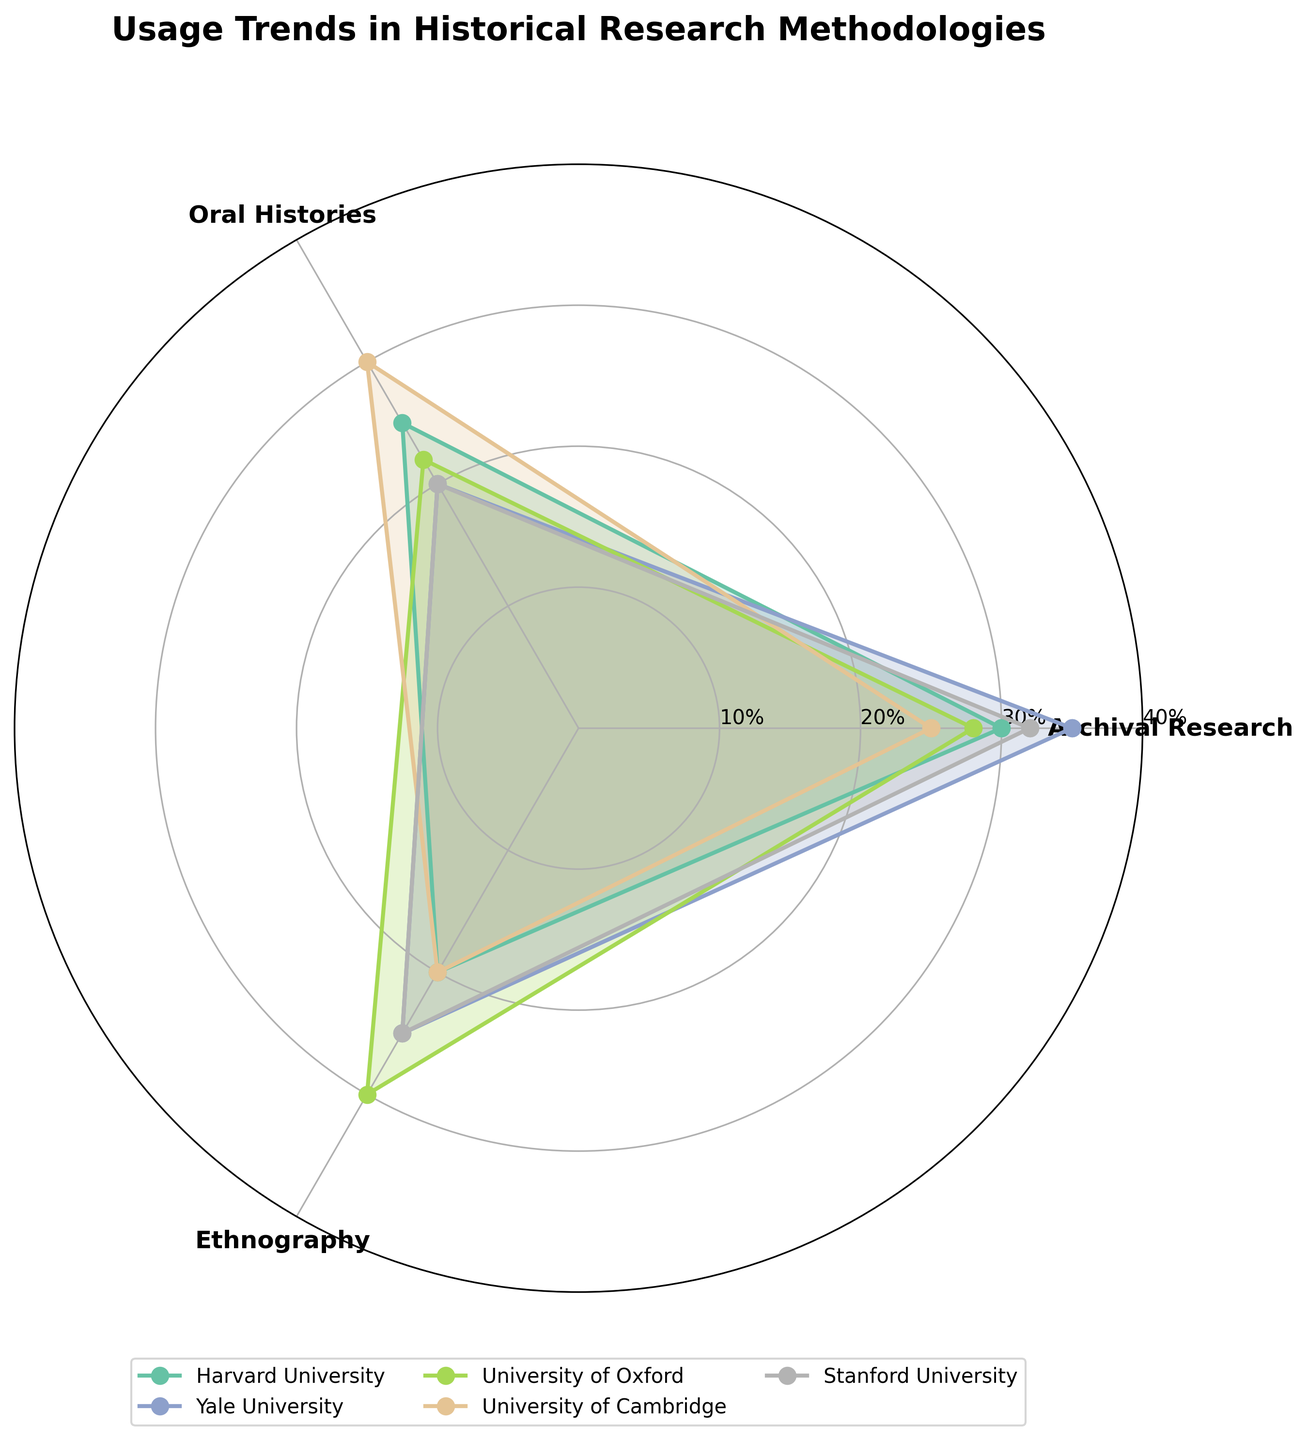What is the title of the figure? The title of the figure is usually displayed at the top center. In this case, the title is present and reads "Usage Trends in Historical Research Methodologies".
Answer: Usage Trends in Historical Research Methodologies How many academic institutions are represented in the chart? The chart represents each institution with a different line and color. By counting the segments, we see there are five institutions: Harvard University, Yale University, University of Oxford, University of Cambridge, and Stanford University.
Answer: Five Which institution has the highest usage percentage for Archival Research? By observing the Archival Research segment for each institution (identified by the color-coded lines), we find that Yale University has the highest percentage at 35%.
Answer: Yale University What is the average usage percentage for Oral Histories across all institutions? Sum the usage percentages for Oral Histories for each institution and then divide by the number of institutions: (25 + 20 + 22 + 30 + 20) / 5 = 23.4%
Answer: 23.4% Which research methodology shows the highest overall usage by any institution, and which institution does it correspond to? Review the maximum values for each methodology across all institutions. Archival Research has the highest percentage at 35%, corresponding to Yale University.
Answer: Archival Research, Yale University Compare the usage percentages of Ethnography between Harvard University and University of Oxford. Which one has a higher percentage? The values for Ethnography are compared for both institutions: Harvard University (20%) and University of Oxford (30%). University of Oxford has a higher percentage.
Answer: University of Oxford What is the total usage percentage of all methodologies combined for Stanford University? Sum up all usage percentages for Stanford University: 32% (Archival Research) + 20% (Oral Histories) + 25% (Ethnography) = 77%.
Answer: 77% Which institution has the least variability in the usage of different methodologies? Variability can be assessed by checking the range (difference between maximum and minimum values) for each institution. Calculate ranges: Harvard (10), Yale (15), Oxford (8), Cambridge (10), Stanford (12). University of Oxford has the least variability.
Answer: University of Oxford How does the usage percentage of Oral Histories in Cambridge compare to Ethnography in the same institution? Review the values for Cambridge: Oral Histories (30%) and Ethnography (20%). Oral Histories has a higher percentage than Ethnography.
Answer: Oral Histories is higher Which methodological usage pattern forms the smallest area on the polar chart, indicating the lowest overall usage among the institutions? Identify the methodology with the lowest corresponding values on the chart. Oral Histories have relatively lower percentages compared to the others, thus forming the smallest area.
Answer: Oral Histories 